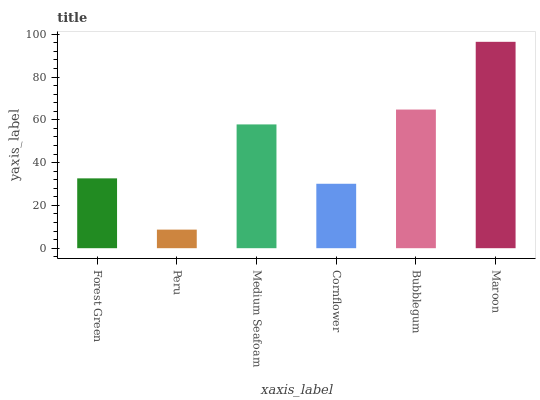Is Peru the minimum?
Answer yes or no. Yes. Is Maroon the maximum?
Answer yes or no. Yes. Is Medium Seafoam the minimum?
Answer yes or no. No. Is Medium Seafoam the maximum?
Answer yes or no. No. Is Medium Seafoam greater than Peru?
Answer yes or no. Yes. Is Peru less than Medium Seafoam?
Answer yes or no. Yes. Is Peru greater than Medium Seafoam?
Answer yes or no. No. Is Medium Seafoam less than Peru?
Answer yes or no. No. Is Medium Seafoam the high median?
Answer yes or no. Yes. Is Forest Green the low median?
Answer yes or no. Yes. Is Cornflower the high median?
Answer yes or no. No. Is Bubblegum the low median?
Answer yes or no. No. 